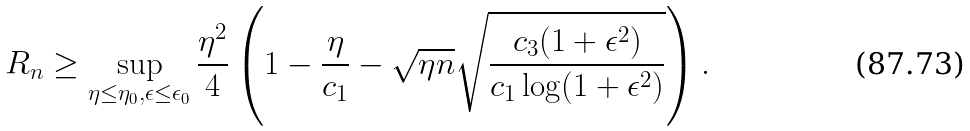Convert formula to latex. <formula><loc_0><loc_0><loc_500><loc_500>R _ { n } \geq \sup _ { \eta \leq \eta _ { 0 } , \epsilon \leq \epsilon _ { 0 } } \frac { \eta ^ { 2 } } { 4 } \left ( 1 - \frac { \eta } { c _ { 1 } } - \sqrt { \eta n } \sqrt { \frac { c _ { 3 } ( 1 + \epsilon ^ { 2 } ) } { c _ { 1 } \log ( 1 + \epsilon ^ { 2 } ) } } \right ) .</formula> 